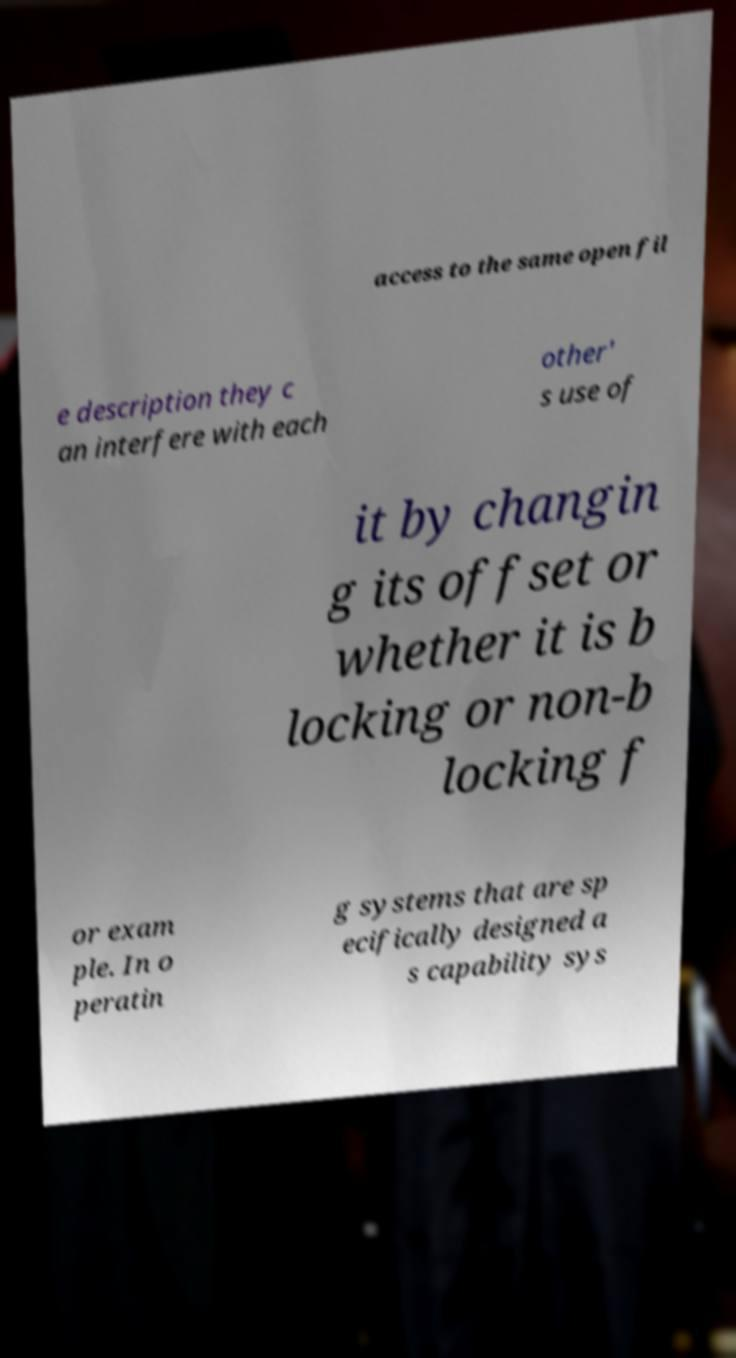Please identify and transcribe the text found in this image. access to the same open fil e description they c an interfere with each other' s use of it by changin g its offset or whether it is b locking or non-b locking f or exam ple. In o peratin g systems that are sp ecifically designed a s capability sys 